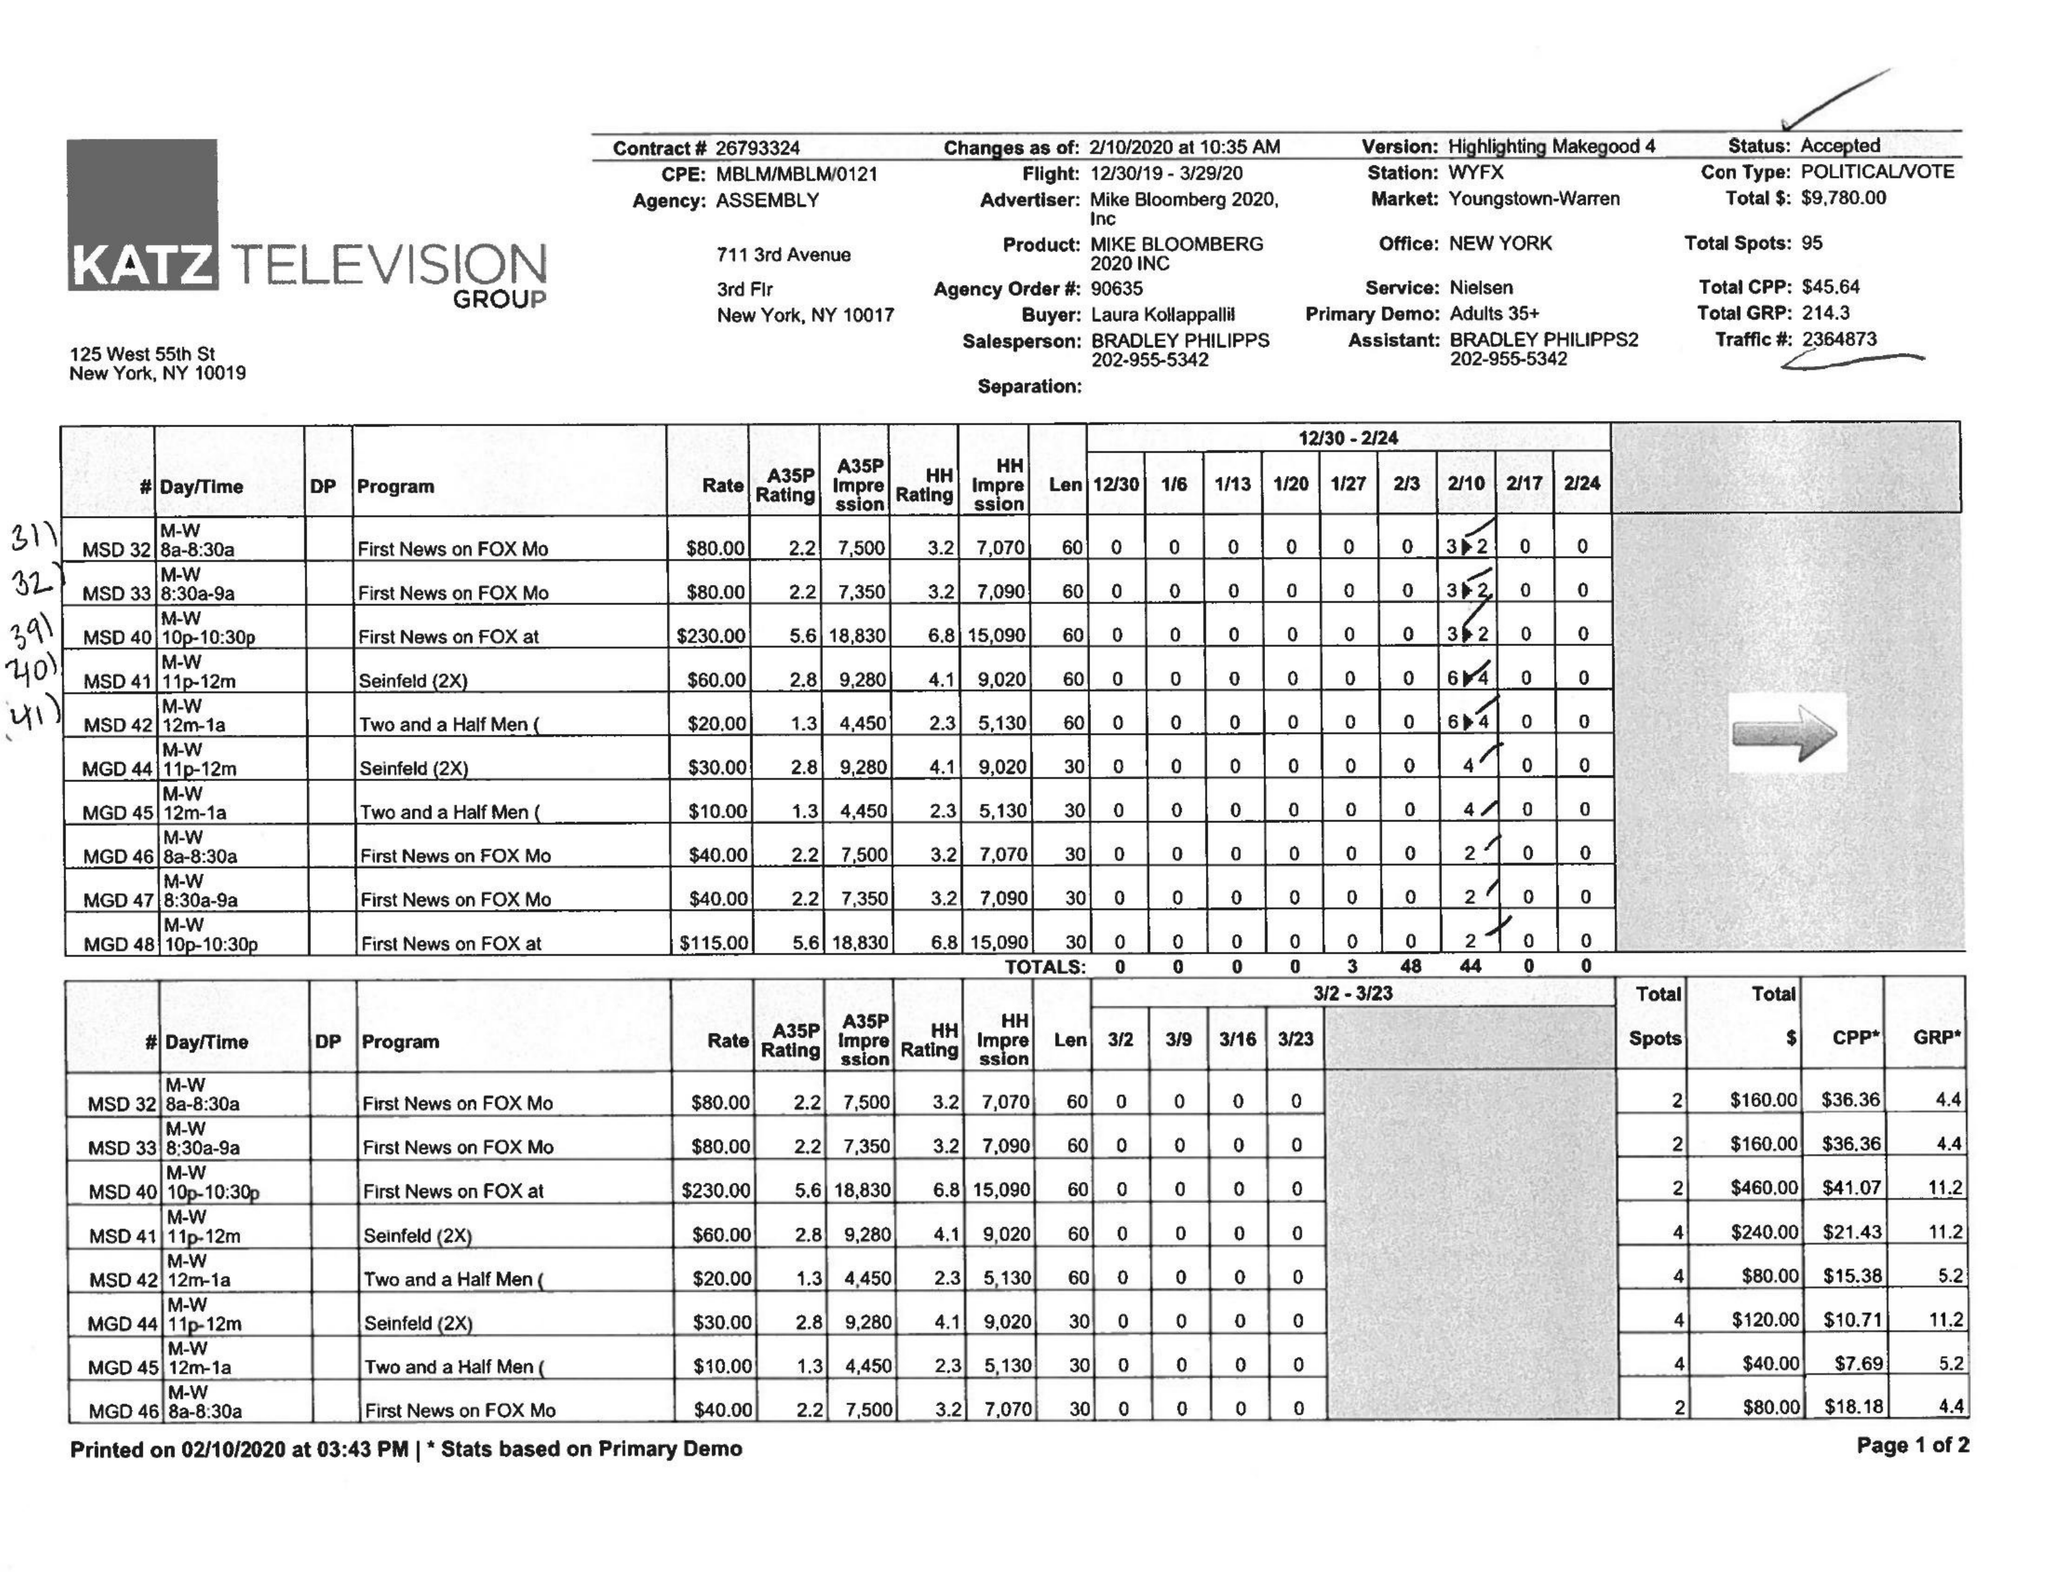What is the value for the gross_amount?
Answer the question using a single word or phrase. 9780.00 